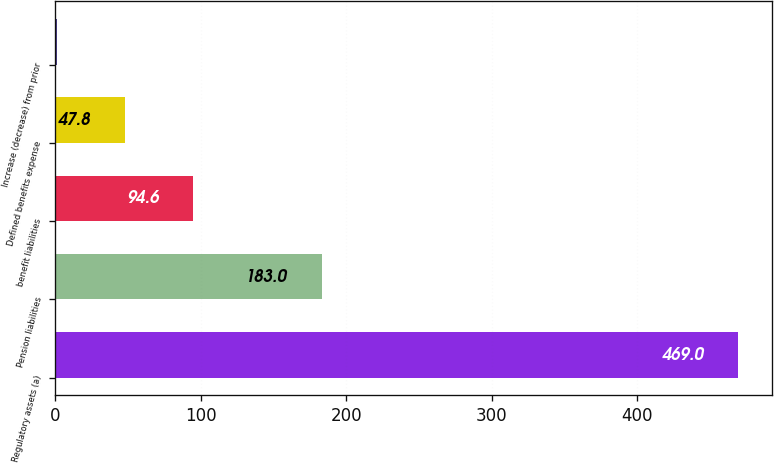Convert chart to OTSL. <chart><loc_0><loc_0><loc_500><loc_500><bar_chart><fcel>Regulatory assets (a)<fcel>Pension liabilities<fcel>benefit liabilities<fcel>Defined benefits expense<fcel>Increase (decrease) from prior<nl><fcel>469<fcel>183<fcel>94.6<fcel>47.8<fcel>1<nl></chart> 